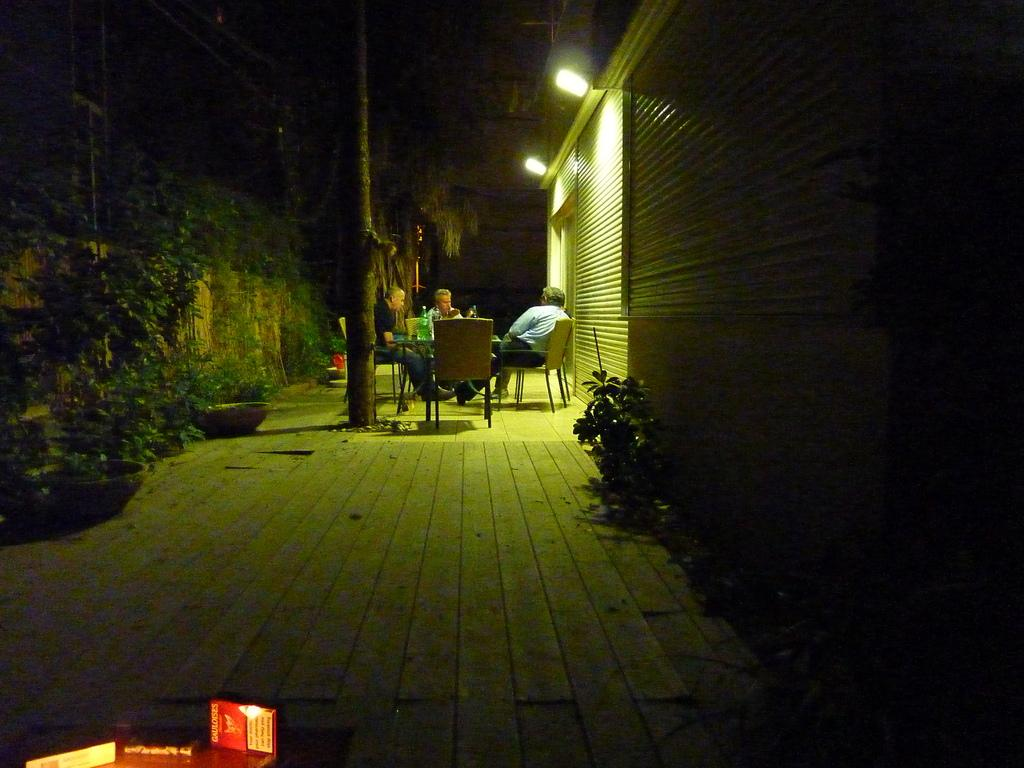What type of structures can be seen in the image? There are buildings in the image. What can be observed illuminating the scene? There are lights in the image. What type of vegetation is present in the image? There are plants and trees in the image. What are the people in the image doing? The people are sitting on chairs in the image. What piece of furniture is present in the image? There is a table in the image. What object is on the table? There is a bottle on the table. How would you describe the overall lighting in the image? The image is slightly dark. Can you see any steam coming from the bottle in the image? There is no steam present in the image. Is this image taken in an alley? The image does not depict an alley; it shows a scene with buildings, lights, plants, trees, people, chairs, a table, and a bottle. --- Facts: 1. There is a car in the image. 2. The car is red. 3. The car has four wheels. 4. There are people standing near the car. 5. The people are holding bags. 6. The background of the image is a cityscape. Absurd Topics: parrot, sand, mountain Conversation: What is the main subject of the image? The main subject of the image is a car. What color is the car? The car is red. How many wheels does the car have? The car has four wheels. What are the people near the car doing? The people are standing near the car and holding bags. What can be seen in the background of the image? The background of the image is a cityscape. Reasoning: Let's think step by step in order to produce the conversation. We start by identifying the main subject of the image, which is the car. Then, we describe specific features of the car, such as its color and the number of wheels. Next, we observe the actions of the people in the image, noting that they are standing near the car and holding bags. Finally, we describe the background of the image, which is a cityscape. Absurd Question/Answer: Can you see a parrot perched on the car in the image? There is no parrot present in the image. Is there a mountain visible in the background of the image? The background of the image is a cityscape, not a mountainous landscape. 